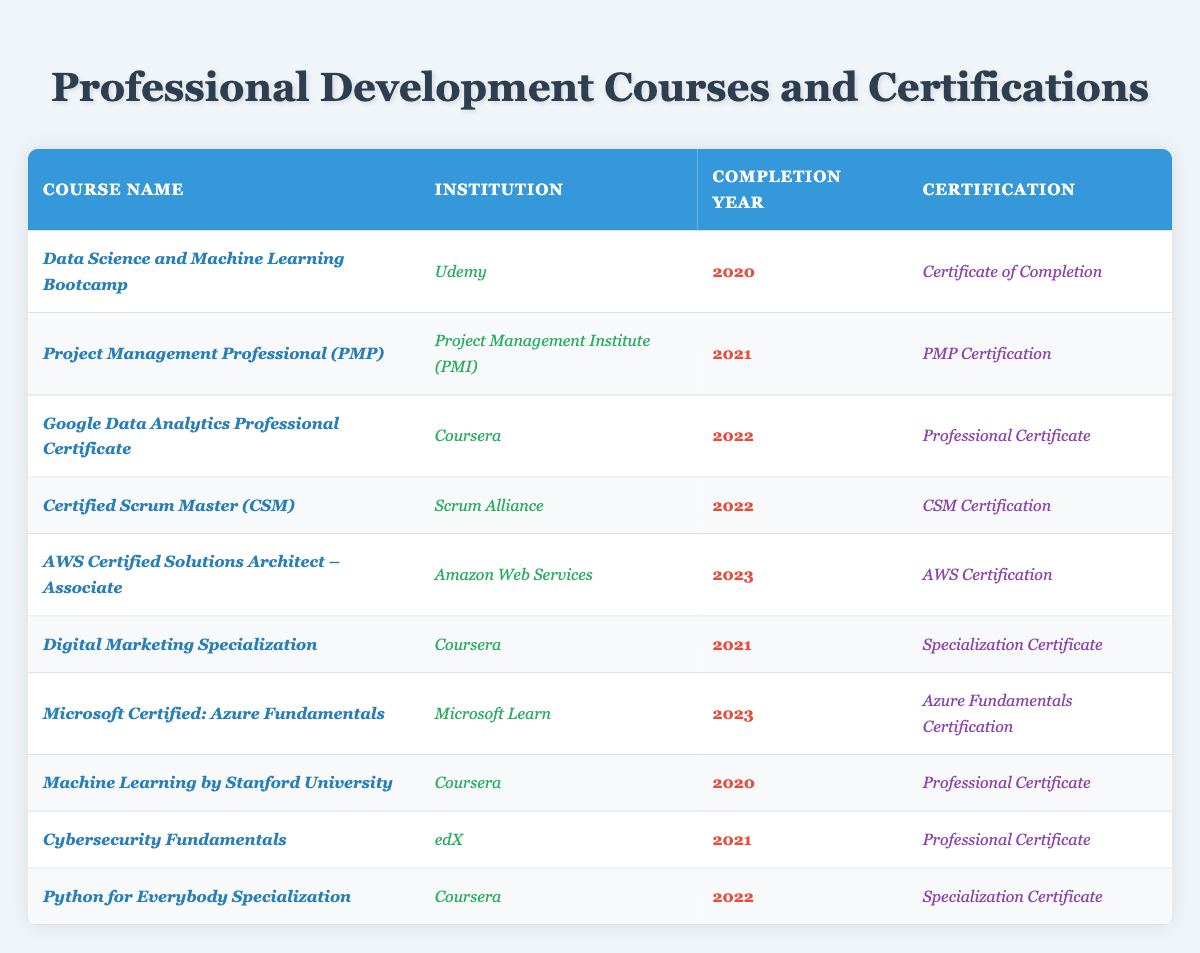What is the name of the course completed in 2023? From the table, we can look for the entry with the completion year listed as 2023. There are two courses listed for that year: "AWS Certified Solutions Architect – Associate" and "Microsoft Certified: Azure Fundamentals."
Answer: "AWS Certified Solutions Architect – Associate" and "Microsoft Certified: Azure Fundamentals" How many courses were completed in 2021? By counting the entries in the table that have the completion year of 2021, we find that there are three courses: "Project Management Professional (PMP)," "Digital Marketing Specialization," and "Cybersecurity Fundamentals."
Answer: 3 What certification did Wilfredo receive from the course on Project Management? The course on Project Management is "Project Management Professional (PMP)" and its certification is listed as "PMP Certification." We can directly read this from the corresponding row in the table.
Answer: "PMP Certification" Which institution offered the course "Machine Learning by Stanford University"? According to the table, the "Machine Learning by Stanford University" course was offered by "Coursera," which is specified in the appropriate column within that row.
Answer: "Coursera" Is there any course that provides a certificate related to Digital Marketing? Yes, there is a course called "Digital Marketing Specialization" which provides a certificate listed as "Specialization Certificate." We verify this by checking the entry for that course in the table.
Answer: Yes What is the average completion year for the courses listed? The courses were completed in the years 2020, 2021, 2022, and 2023. To find the average, we calculate the sum (2020 + 2021 + 2022 + 2023) and then divide by the number of courses (10): (2020 + 2021 + 2022 + 2023)/10 = 2021.
Answer: 2021 What percentage of the courses were completed in 2022? We have a total of 10 courses, and 3 of them were completed in 2022 (Google Data Analytics Professional Certificate, Certified Scrum Master (CSM), and Python for Everybody Specialization). The percentage is (3/10) * 100 = 30%.
Answer: 30% How many unique institutions offered these courses? By reviewing the table, the institutions listed are Udemy, Project Management Institute (PMI), Coursera, Scrum Alliance, Amazon Web Services, Microsoft Learn, and edX. Counting these gives us a total of 7 unique institutions.
Answer: 7 Which course has the earliest completion year, and what is its certification? "Data Science and Machine Learning Bootcamp" is the course with the earliest completion year, which is 2020. Its certification is "Certificate of Completion," as stated in that particular row of the table.
Answer: "Data Science and Machine Learning Bootcamp" and "Certificate of Completion" Did Wilfredo pursue any course related to Cybersecurity? Yes, there is a course titled "Cybersecurity Fundamentals" listed in the table, indicating that Wilfredo pursued this course related to Cybersecurity, with the corresponding certification as "Professional Certificate."
Answer: Yes 